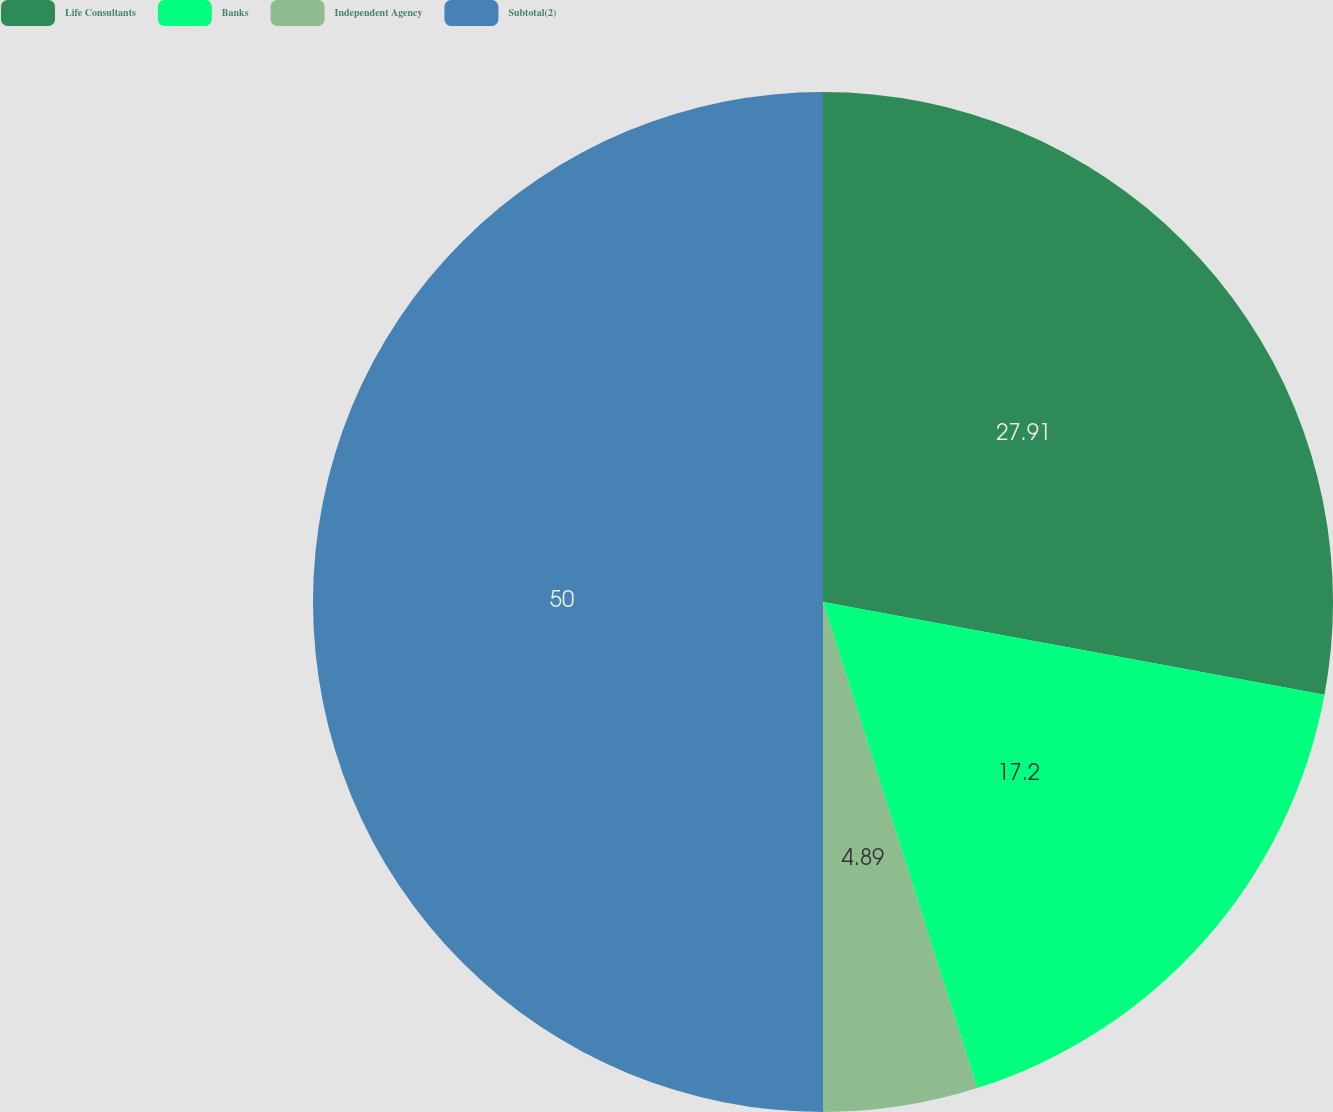<chart> <loc_0><loc_0><loc_500><loc_500><pie_chart><fcel>Life Consultants<fcel>Banks<fcel>Independent Agency<fcel>Subtotal(2)<nl><fcel>27.91%<fcel>17.2%<fcel>4.89%<fcel>50.0%<nl></chart> 